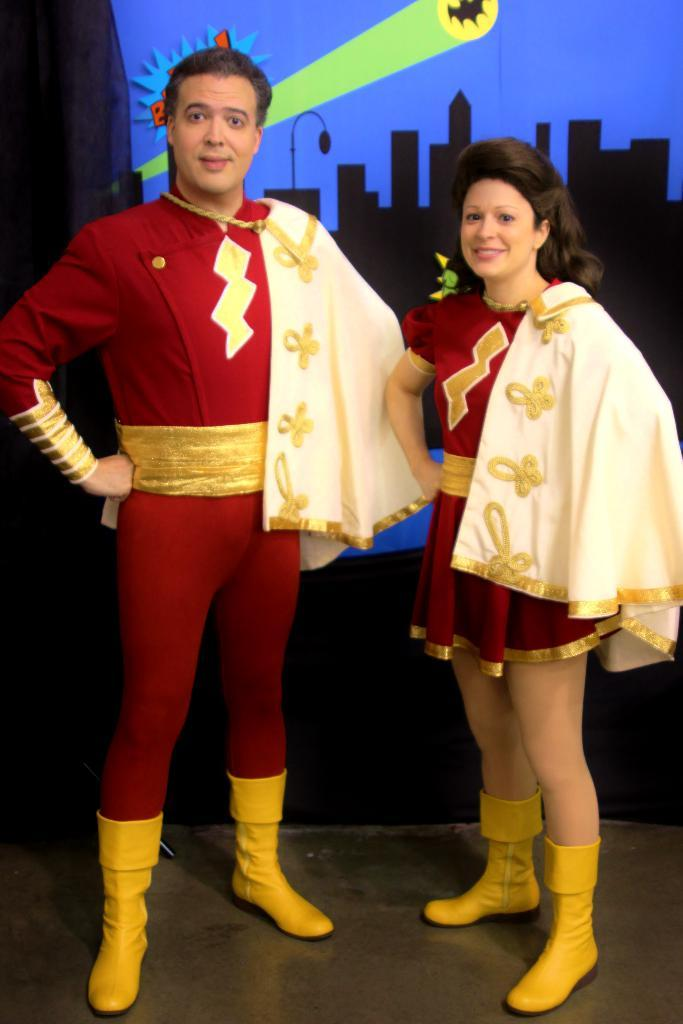How many people are in the image? There are two people in the image. What are the people wearing? Both people are wearing red costumes. What are the people doing in the image? The people are looking and smiling at someone. What type of silver object is being held by the person on the left in the image? There is no silver object visible in the image; both people are wearing red costumes and looking at someone. 